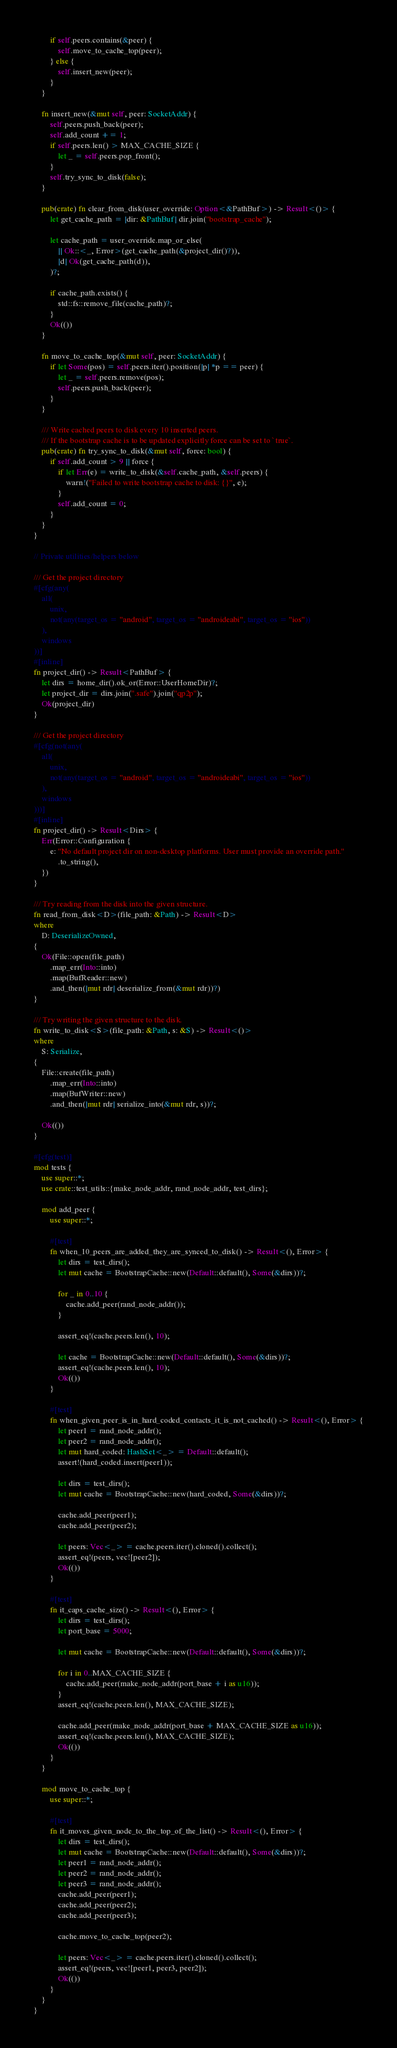Convert code to text. <code><loc_0><loc_0><loc_500><loc_500><_Rust_>
        if self.peers.contains(&peer) {
            self.move_to_cache_top(peer);
        } else {
            self.insert_new(peer);
        }
    }

    fn insert_new(&mut self, peer: SocketAddr) {
        self.peers.push_back(peer);
        self.add_count += 1;
        if self.peers.len() > MAX_CACHE_SIZE {
            let _ = self.peers.pop_front();
        }
        self.try_sync_to_disk(false);
    }

    pub(crate) fn clear_from_disk(user_override: Option<&PathBuf>) -> Result<()> {
        let get_cache_path = |dir: &PathBuf| dir.join("bootstrap_cache");

        let cache_path = user_override.map_or_else(
            || Ok::<_, Error>(get_cache_path(&project_dir()?)),
            |d| Ok(get_cache_path(d)),
        )?;

        if cache_path.exists() {
            std::fs::remove_file(cache_path)?;
        }
        Ok(())
    }

    fn move_to_cache_top(&mut self, peer: SocketAddr) {
        if let Some(pos) = self.peers.iter().position(|p| *p == peer) {
            let _ = self.peers.remove(pos);
            self.peers.push_back(peer);
        }
    }

    /// Write cached peers to disk every 10 inserted peers.
    /// If the bootstrap cache is to be updated explicitly force can be set to `true`.
    pub(crate) fn try_sync_to_disk(&mut self, force: bool) {
        if self.add_count > 9 || force {
            if let Err(e) = write_to_disk(&self.cache_path, &self.peers) {
                warn!("Failed to write bootstrap cache to disk: {}", e);
            }
            self.add_count = 0;
        }
    }
}

// Private utilities/helpers below

/// Get the project directory
#[cfg(any(
    all(
        unix,
        not(any(target_os = "android", target_os = "androideabi", target_os = "ios"))
    ),
    windows
))]
#[inline]
fn project_dir() -> Result<PathBuf> {
    let dirs = home_dir().ok_or(Error::UserHomeDir)?;
    let project_dir = dirs.join(".safe").join("qp2p");
    Ok(project_dir)
}

/// Get the project directory
#[cfg(not(any(
    all(
        unix,
        not(any(target_os = "android", target_os = "androideabi", target_os = "ios"))
    ),
    windows
)))]
#[inline]
fn project_dir() -> Result<Dirs> {
    Err(Error::Configuration {
        e: "No default project dir on non-desktop platforms. User must provide an override path."
            .to_string(),
    })
}

/// Try reading from the disk into the given structure.
fn read_from_disk<D>(file_path: &Path) -> Result<D>
where
    D: DeserializeOwned,
{
    Ok(File::open(file_path)
        .map_err(Into::into)
        .map(BufReader::new)
        .and_then(|mut rdr| deserialize_from(&mut rdr))?)
}

/// Try writing the given structure to the disk.
fn write_to_disk<S>(file_path: &Path, s: &S) -> Result<()>
where
    S: Serialize,
{
    File::create(file_path)
        .map_err(Into::into)
        .map(BufWriter::new)
        .and_then(|mut rdr| serialize_into(&mut rdr, s))?;

    Ok(())
}

#[cfg(test)]
mod tests {
    use super::*;
    use crate::test_utils::{make_node_addr, rand_node_addr, test_dirs};

    mod add_peer {
        use super::*;

        #[test]
        fn when_10_peers_are_added_they_are_synced_to_disk() -> Result<(), Error> {
            let dirs = test_dirs();
            let mut cache = BootstrapCache::new(Default::default(), Some(&dirs))?;

            for _ in 0..10 {
                cache.add_peer(rand_node_addr());
            }

            assert_eq!(cache.peers.len(), 10);

            let cache = BootstrapCache::new(Default::default(), Some(&dirs))?;
            assert_eq!(cache.peers.len(), 10);
            Ok(())
        }

        #[test]
        fn when_given_peer_is_in_hard_coded_contacts_it_is_not_cached() -> Result<(), Error> {
            let peer1 = rand_node_addr();
            let peer2 = rand_node_addr();
            let mut hard_coded: HashSet<_> = Default::default();
            assert!(hard_coded.insert(peer1));

            let dirs = test_dirs();
            let mut cache = BootstrapCache::new(hard_coded, Some(&dirs))?;

            cache.add_peer(peer1);
            cache.add_peer(peer2);

            let peers: Vec<_> = cache.peers.iter().cloned().collect();
            assert_eq!(peers, vec![peer2]);
            Ok(())
        }

        #[test]
        fn it_caps_cache_size() -> Result<(), Error> {
            let dirs = test_dirs();
            let port_base = 5000;

            let mut cache = BootstrapCache::new(Default::default(), Some(&dirs))?;

            for i in 0..MAX_CACHE_SIZE {
                cache.add_peer(make_node_addr(port_base + i as u16));
            }
            assert_eq!(cache.peers.len(), MAX_CACHE_SIZE);

            cache.add_peer(make_node_addr(port_base + MAX_CACHE_SIZE as u16));
            assert_eq!(cache.peers.len(), MAX_CACHE_SIZE);
            Ok(())
        }
    }

    mod move_to_cache_top {
        use super::*;

        #[test]
        fn it_moves_given_node_to_the_top_of_the_list() -> Result<(), Error> {
            let dirs = test_dirs();
            let mut cache = BootstrapCache::new(Default::default(), Some(&dirs))?;
            let peer1 = rand_node_addr();
            let peer2 = rand_node_addr();
            let peer3 = rand_node_addr();
            cache.add_peer(peer1);
            cache.add_peer(peer2);
            cache.add_peer(peer3);

            cache.move_to_cache_top(peer2);

            let peers: Vec<_> = cache.peers.iter().cloned().collect();
            assert_eq!(peers, vec![peer1, peer3, peer2]);
            Ok(())
        }
    }
}
</code> 